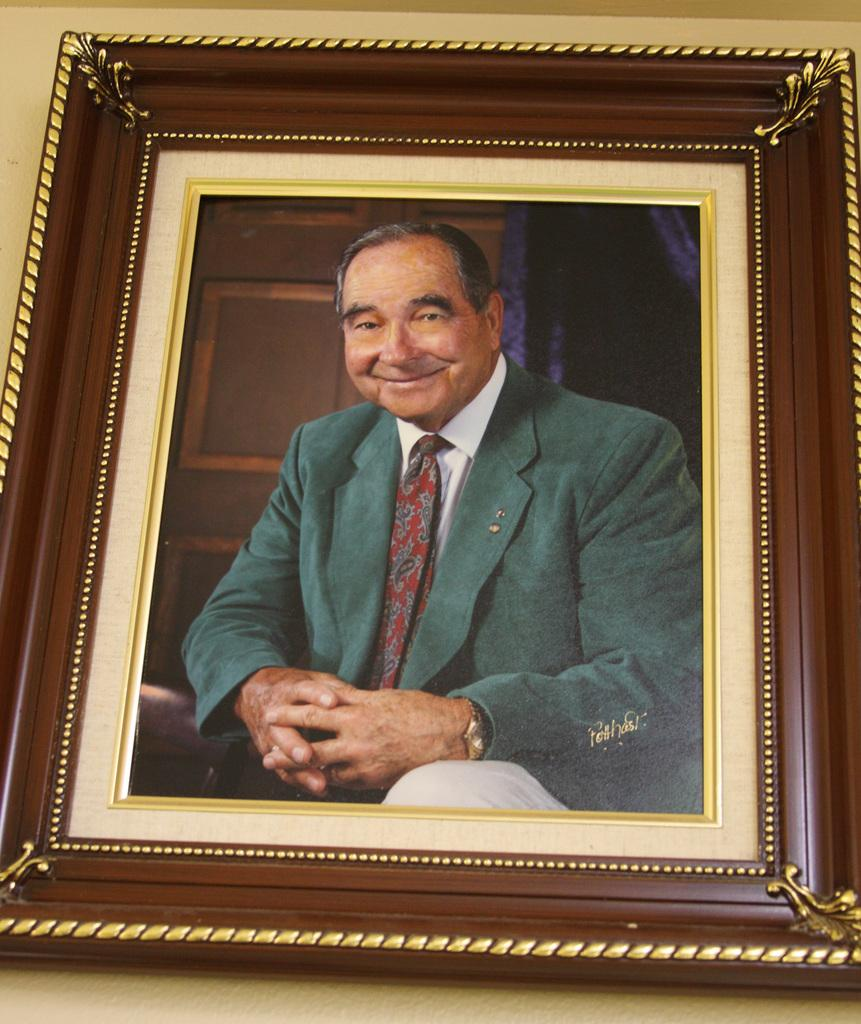What can be seen on the wall in the image? There is a photo frame on the wall. What is inside the photo frame? The photo frame contains a picture of a person. Can you hear the goat talking to the person in the picture frame? There is no goat or talking in the image; it only features a wall with a photo frame containing a picture of a person. 